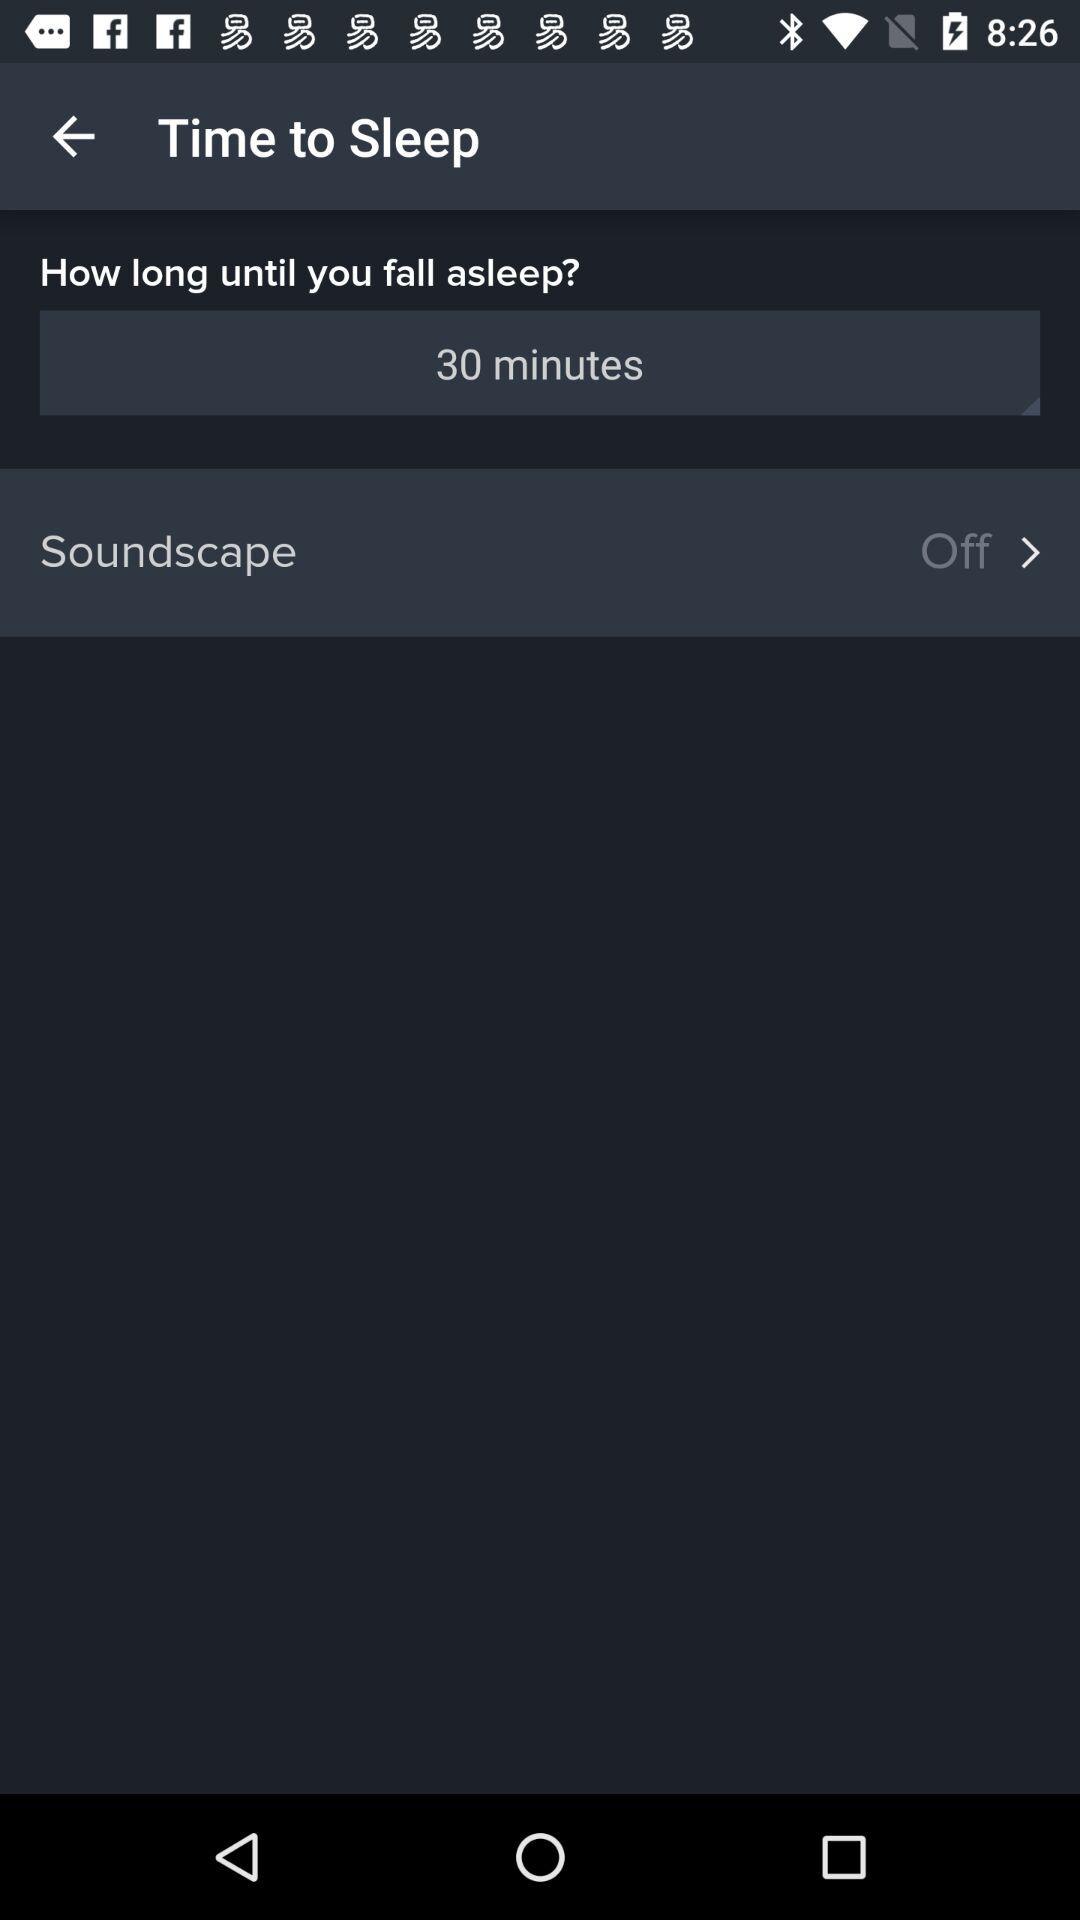How long until you fall asleep? You have 30 minutes until you fall asleep. 